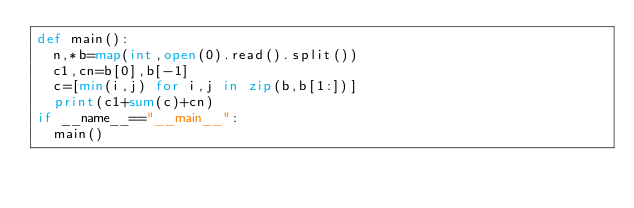Convert code to text. <code><loc_0><loc_0><loc_500><loc_500><_Python_>def main():
  n,*b=map(int,open(0).read().split())
  c1,cn=b[0],b[-1]
  c=[min(i,j) for i,j in zip(b,b[1:])]
  print(c1+sum(c)+cn)
if __name__=="__main__":
  main()</code> 